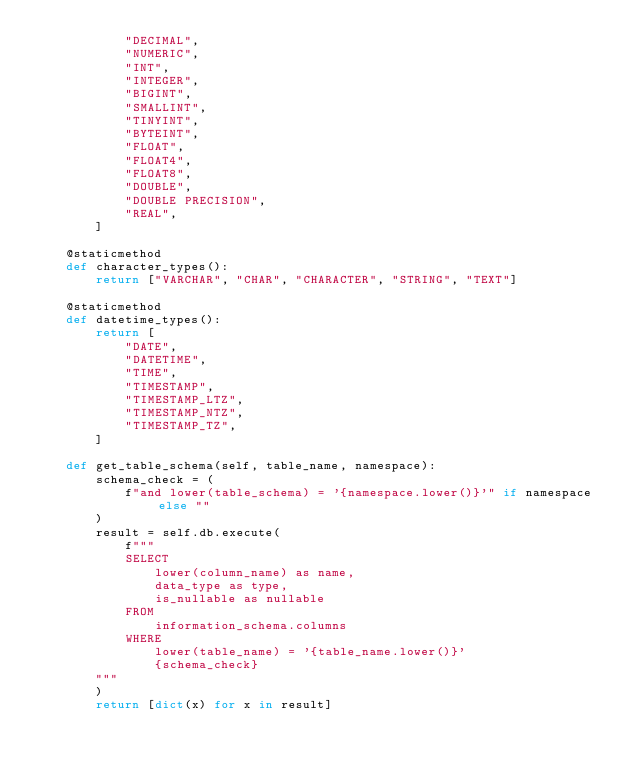<code> <loc_0><loc_0><loc_500><loc_500><_Python_>            "DECIMAL",
            "NUMERIC",
            "INT",
            "INTEGER",
            "BIGINT",
            "SMALLINT",
            "TINYINT",
            "BYTEINT",
            "FLOAT",
            "FLOAT4",
            "FLOAT8",
            "DOUBLE",
            "DOUBLE PRECISION",
            "REAL",
        ]

    @staticmethod
    def character_types():
        return ["VARCHAR", "CHAR", "CHARACTER", "STRING", "TEXT"]

    @staticmethod
    def datetime_types():
        return [
            "DATE",
            "DATETIME",
            "TIME",
            "TIMESTAMP",
            "TIMESTAMP_LTZ",
            "TIMESTAMP_NTZ",
            "TIMESTAMP_TZ",
        ]

    def get_table_schema(self, table_name, namespace):
        schema_check = (
            f"and lower(table_schema) = '{namespace.lower()}'" if namespace else ""
        )
        result = self.db.execute(
            f"""
            SELECT 
                lower(column_name) as name,
                data_type as type,
                is_nullable as nullable
            FROM 
                information_schema.columns
            WHERE 
                lower(table_name) = '{table_name.lower()}'
                {schema_check}
        """
        )
        return [dict(x) for x in result]
</code> 